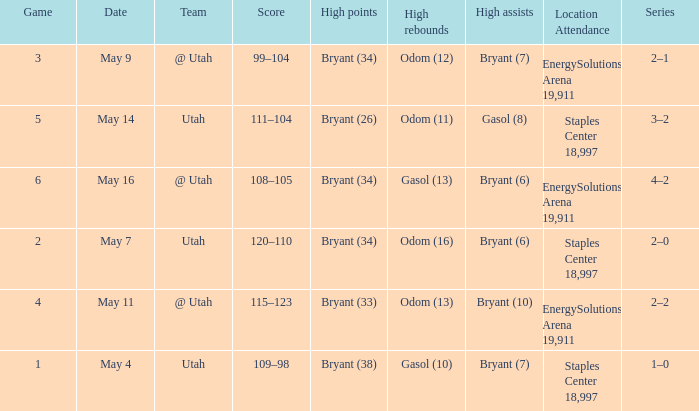What is the Series with a High rebounds with gasol (10)? 1–0. 